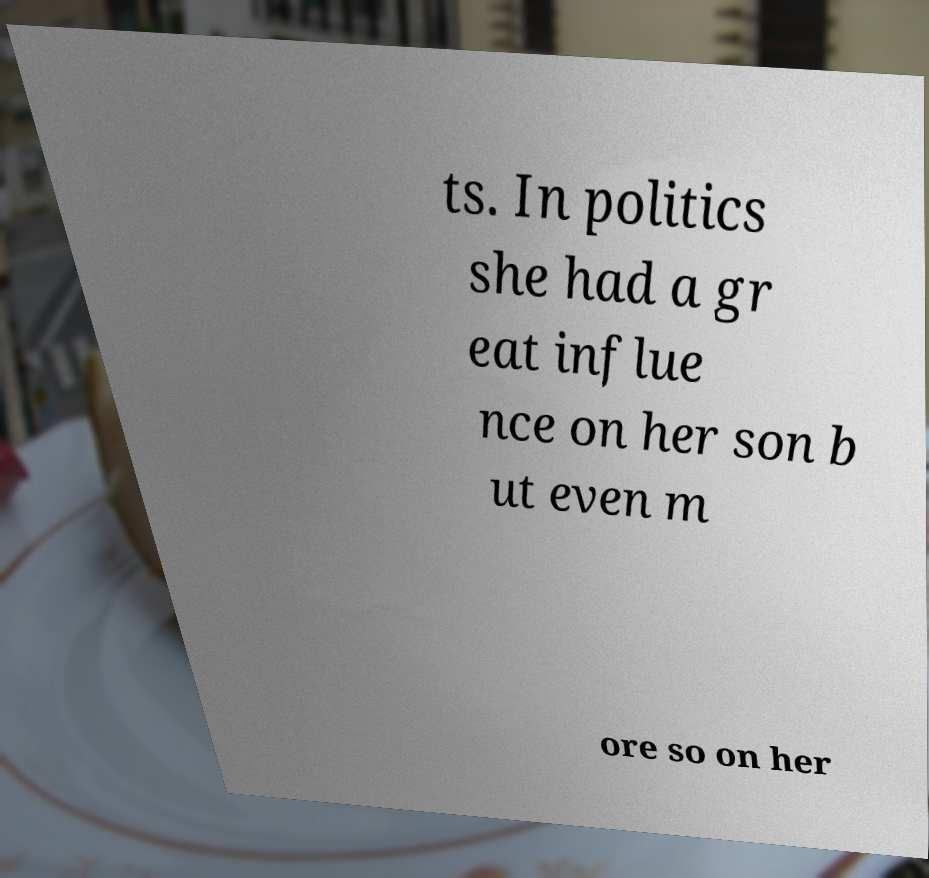Can you read and provide the text displayed in the image?This photo seems to have some interesting text. Can you extract and type it out for me? ts. In politics she had a gr eat influe nce on her son b ut even m ore so on her 